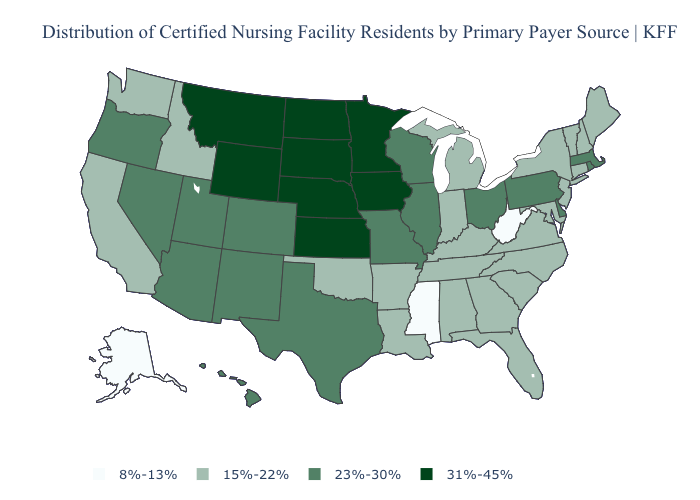Does the map have missing data?
Give a very brief answer. No. Which states have the lowest value in the USA?
Write a very short answer. Alaska, Mississippi, West Virginia. Does Florida have a lower value than Maryland?
Concise answer only. No. Name the states that have a value in the range 8%-13%?
Be succinct. Alaska, Mississippi, West Virginia. Does Illinois have the highest value in the USA?
Short answer required. No. What is the highest value in states that border Arkansas?
Be succinct. 23%-30%. What is the highest value in the South ?
Write a very short answer. 23%-30%. What is the value of Illinois?
Concise answer only. 23%-30%. What is the value of West Virginia?
Give a very brief answer. 8%-13%. What is the value of Texas?
Be succinct. 23%-30%. Does Montana have the highest value in the USA?
Be succinct. Yes. What is the value of Tennessee?
Quick response, please. 15%-22%. What is the value of Maine?
Short answer required. 15%-22%. What is the value of Vermont?
Concise answer only. 15%-22%. What is the value of Georgia?
Answer briefly. 15%-22%. 